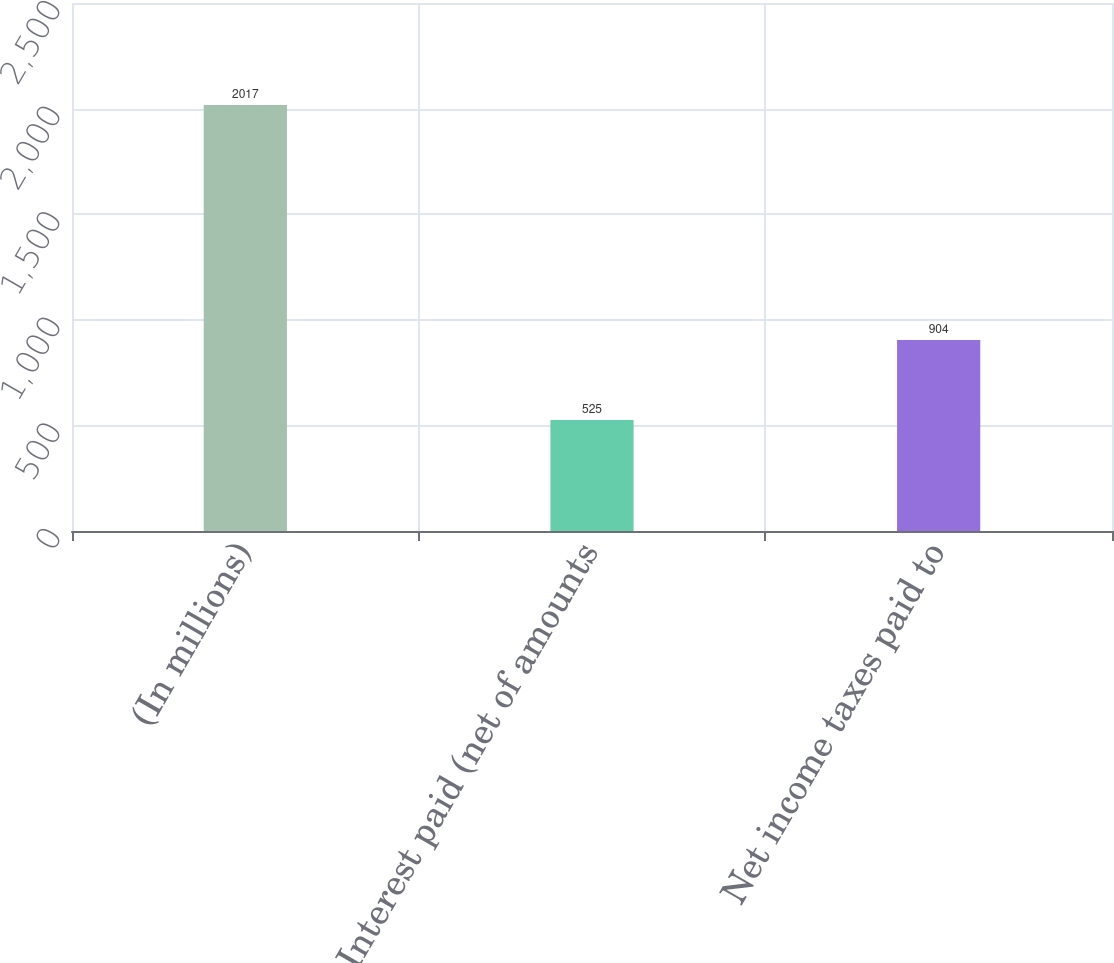<chart> <loc_0><loc_0><loc_500><loc_500><bar_chart><fcel>(In millions)<fcel>Interest paid (net of amounts<fcel>Net income taxes paid to<nl><fcel>2017<fcel>525<fcel>904<nl></chart> 